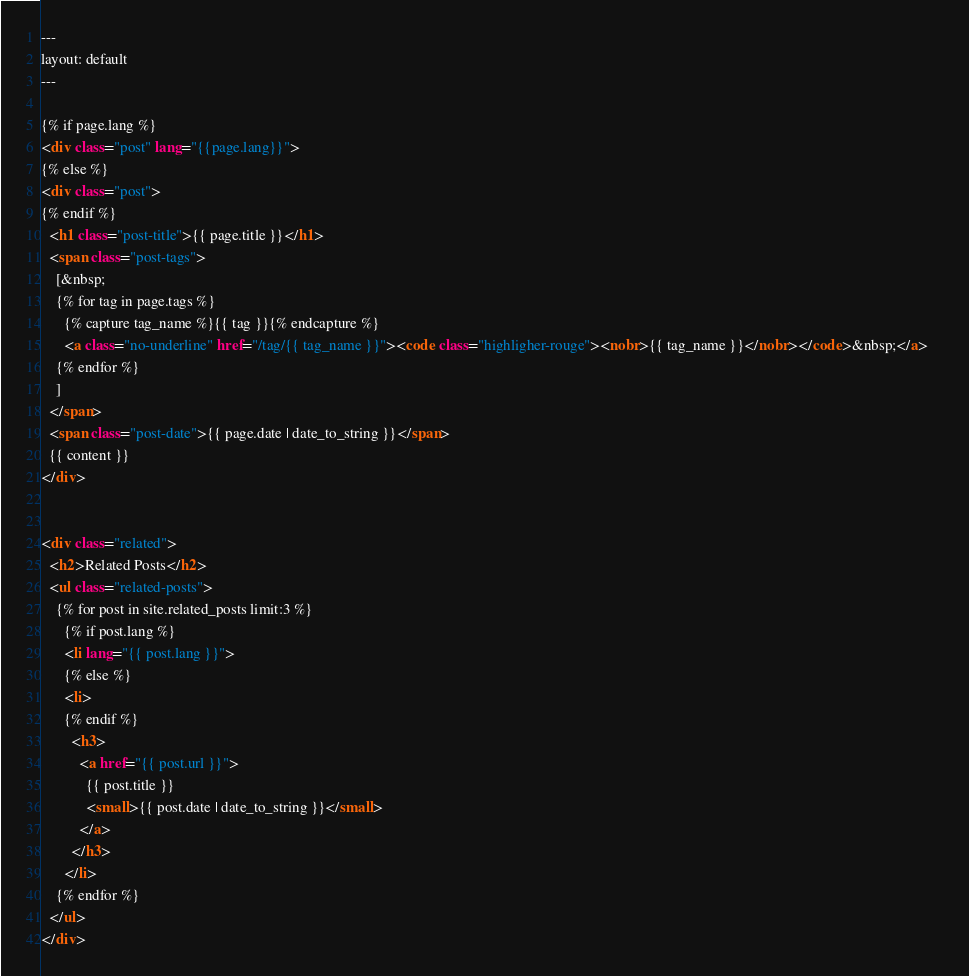Convert code to text. <code><loc_0><loc_0><loc_500><loc_500><_HTML_>---
layout: default
---

{% if page.lang %}
<div class="post" lang="{{page.lang}}">
{% else %}
<div class="post">
{% endif %}
  <h1 class="post-title">{{ page.title }}</h1>
  <span class="post-tags">
    [&nbsp;
    {% for tag in page.tags %}
      {% capture tag_name %}{{ tag }}{% endcapture %}
      <a class="no-underline" href="/tag/{{ tag_name }}"><code class="highligher-rouge"><nobr>{{ tag_name }}</nobr></code>&nbsp;</a>    
    {% endfor %}
    ]
  </span>
  <span class="post-date">{{ page.date | date_to_string }}</span>
  {{ content }}
</div>


<div class="related">
  <h2>Related Posts</h2>
  <ul class="related-posts">
    {% for post in site.related_posts limit:3 %}
      {% if post.lang %}
      <li lang="{{ post.lang }}">
      {% else %}
      <li>
      {% endif %}
        <h3>
          <a href="{{ post.url }}">
            {{ post.title }}
            <small>{{ post.date | date_to_string }}</small>
          </a>
        </h3>
      </li>
    {% endfor %}
  </ul>
</div></code> 